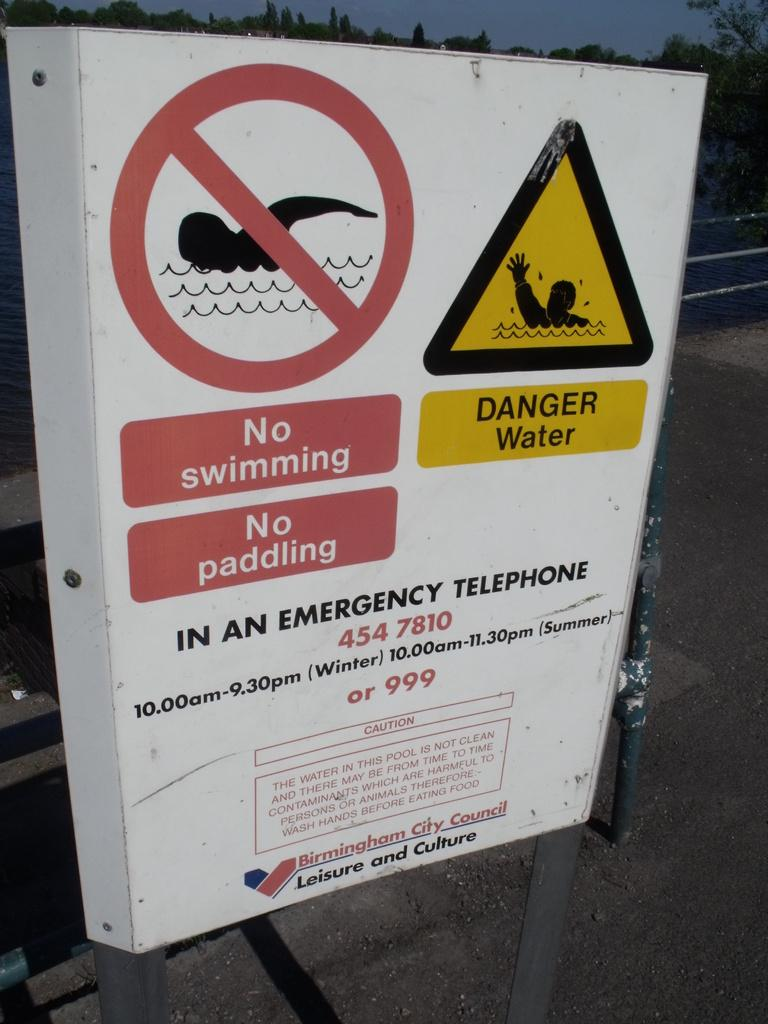<image>
Offer a succinct explanation of the picture presented. A white sign reading No swimming, No paddling, and DANGER Water, with emergency phone numbers underneath. 